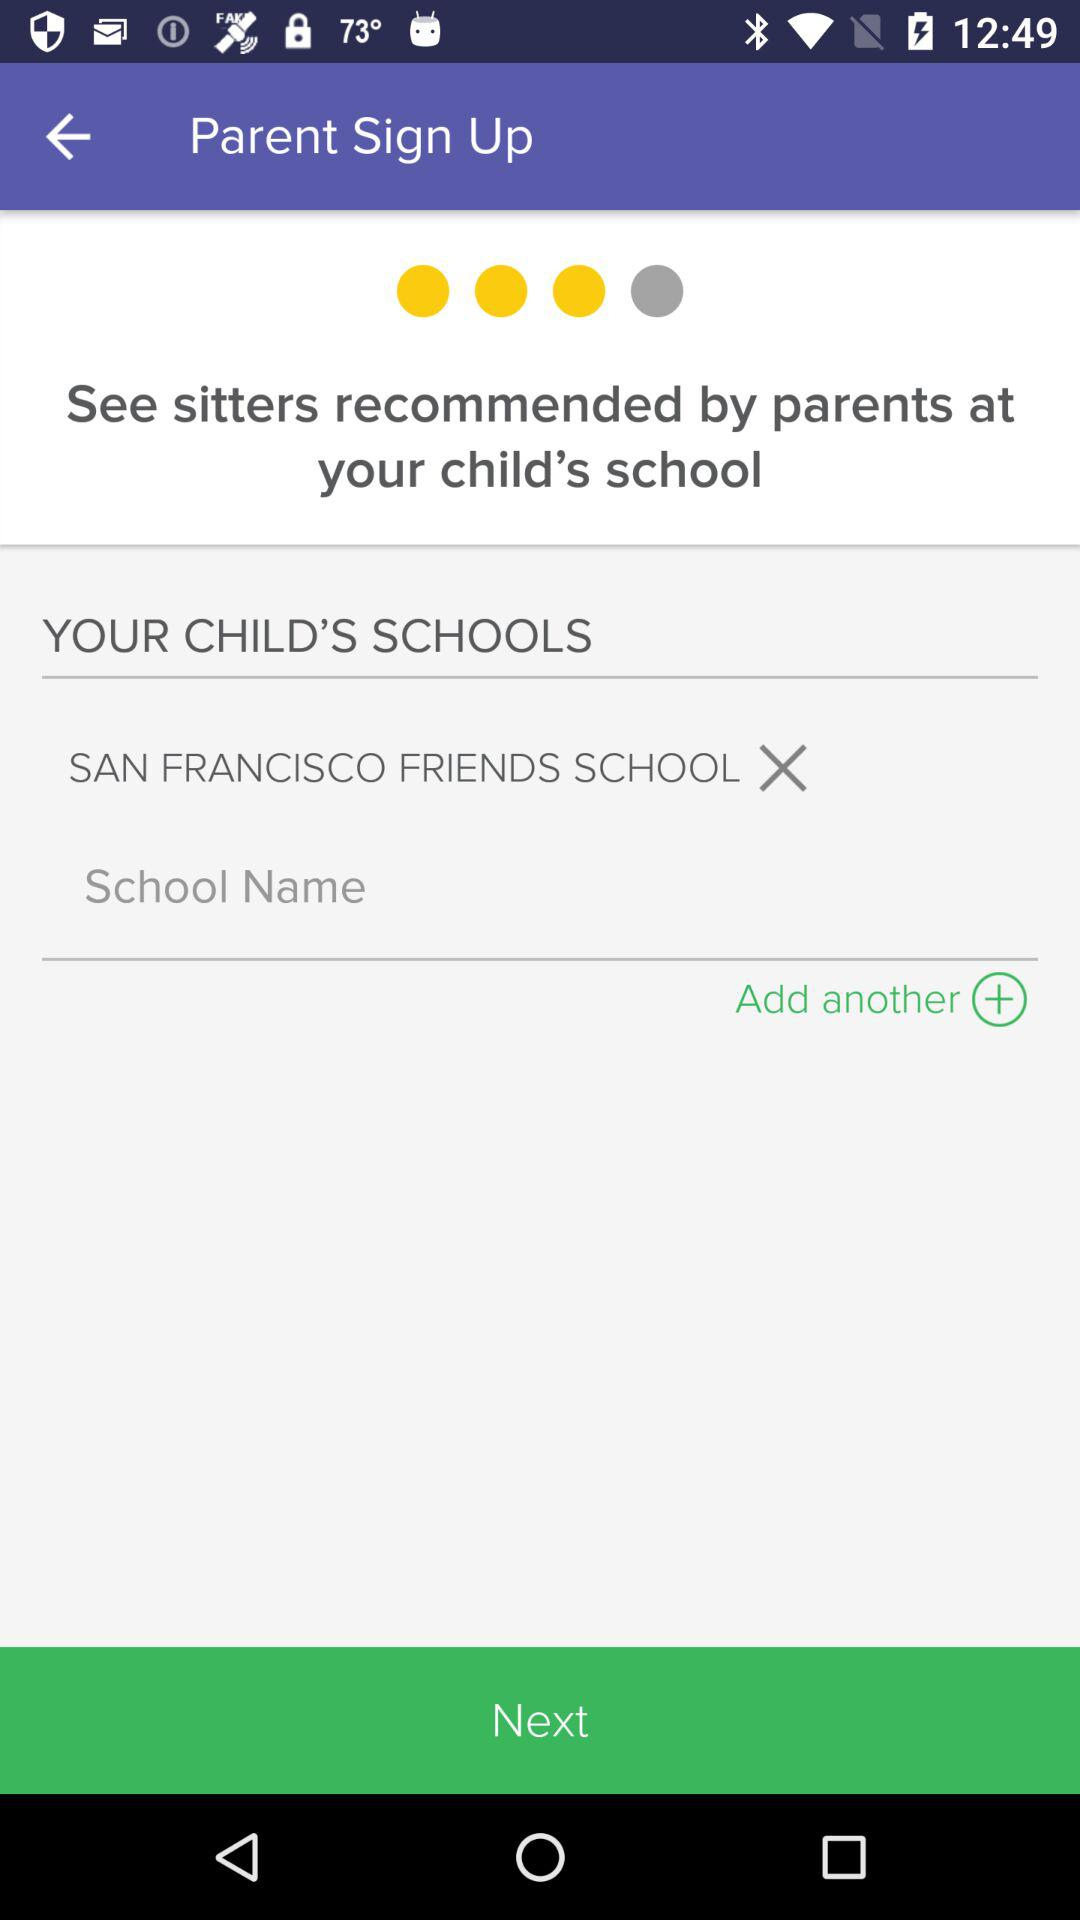How many schools have been added?
Answer the question using a single word or phrase. 1 